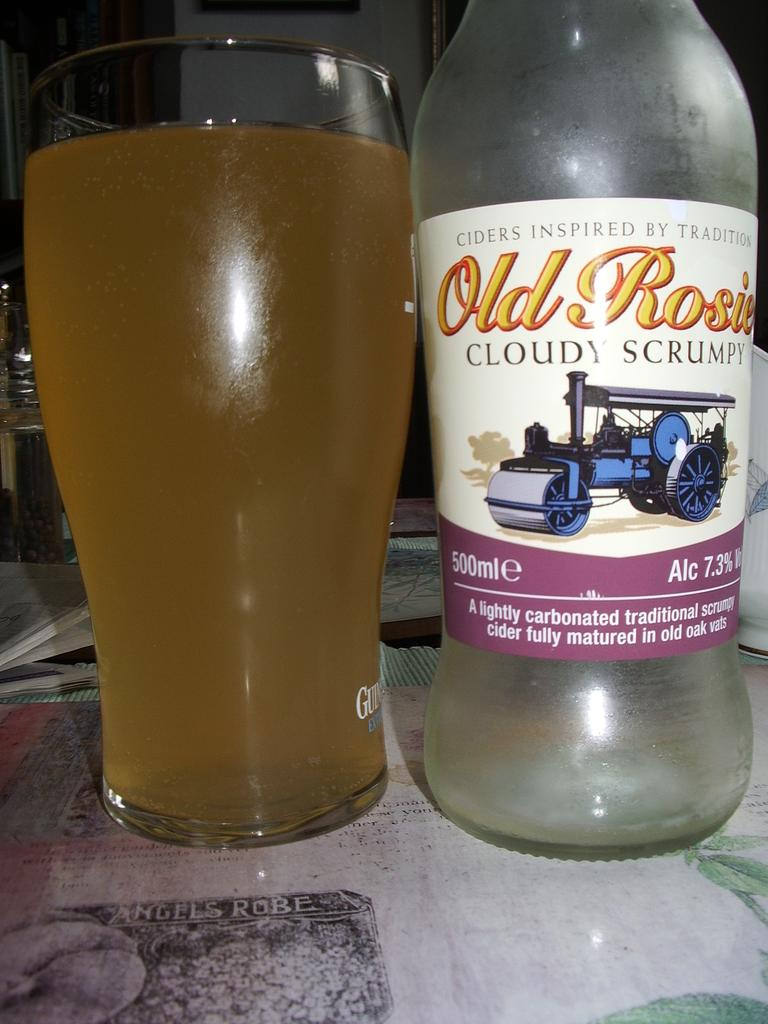<image>
Summarize the visual content of the image. A glass filled with Old Rosie placed next to the bottle. 